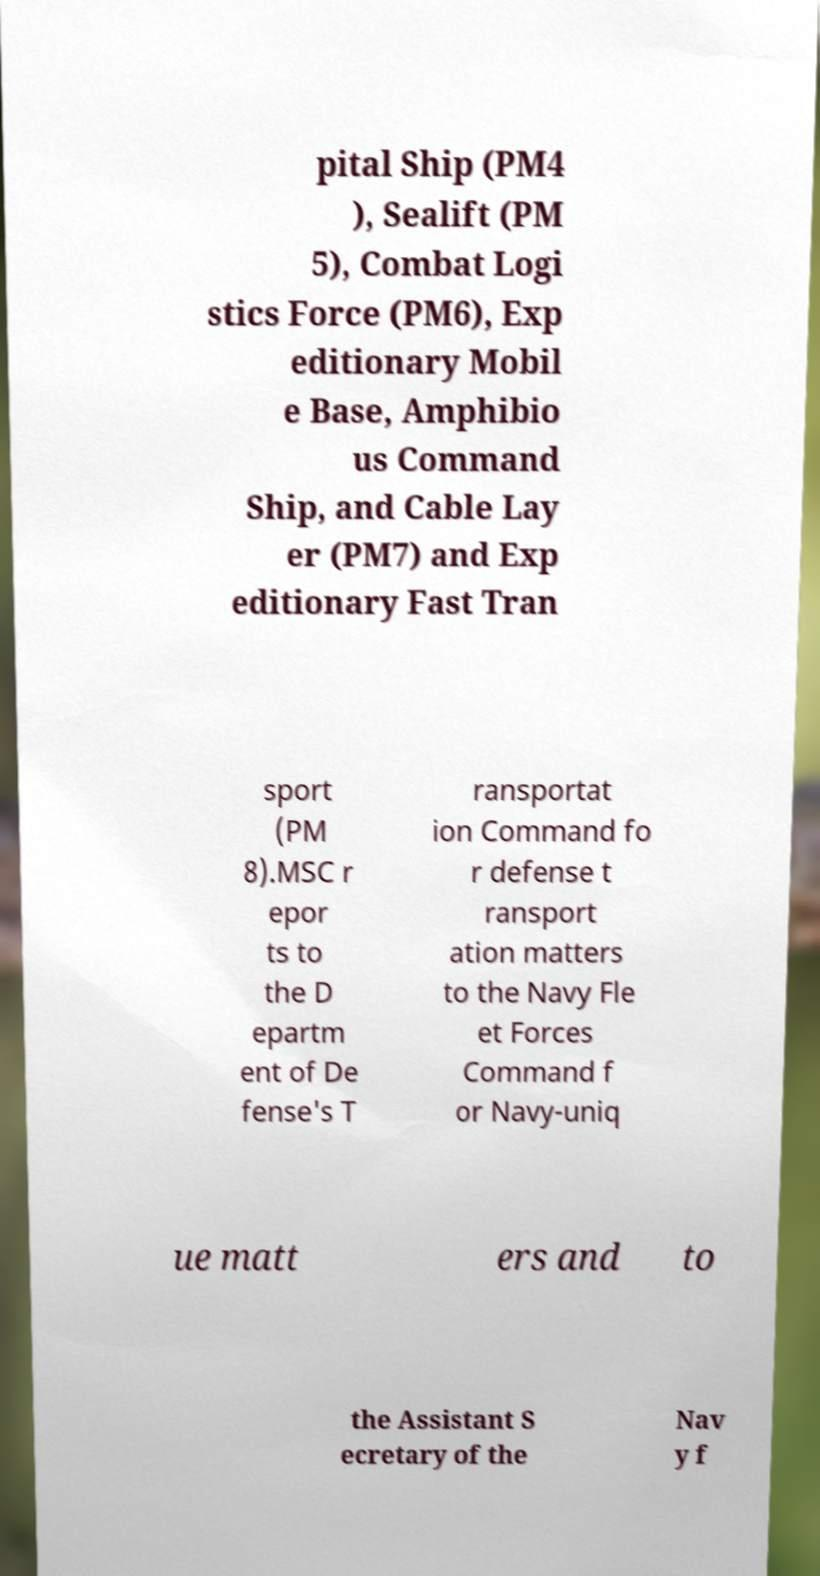What messages or text are displayed in this image? I need them in a readable, typed format. pital Ship (PM4 ), Sealift (PM 5), Combat Logi stics Force (PM6), Exp editionary Mobil e Base, Amphibio us Command Ship, and Cable Lay er (PM7) and Exp editionary Fast Tran sport (PM 8).MSC r epor ts to the D epartm ent of De fense's T ransportat ion Command fo r defense t ransport ation matters to the Navy Fle et Forces Command f or Navy-uniq ue matt ers and to the Assistant S ecretary of the Nav y f 